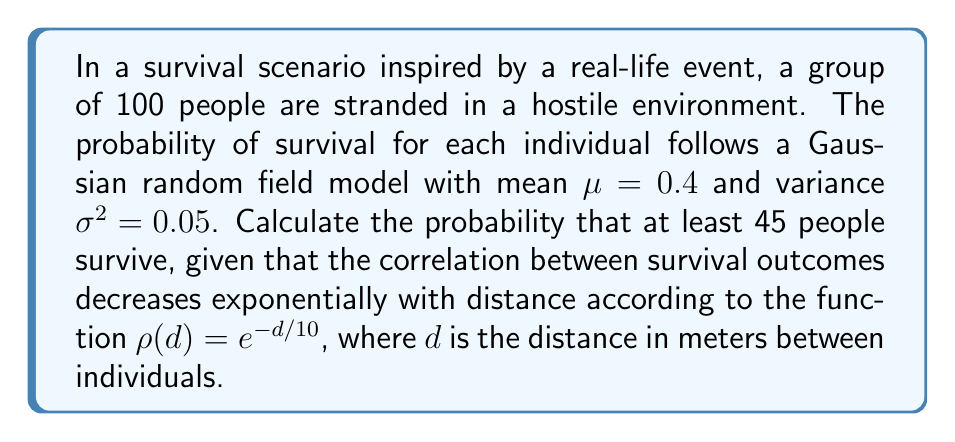What is the answer to this math problem? To solve this problem using field theory, we'll follow these steps:

1) First, we need to understand that we're dealing with a Gaussian random field. The survival probability for each individual is normally distributed with mean $\mu = 0.4$ and variance $\sigma^2 = 0.05$.

2) The correlation between survival outcomes is given by $\rho(d) = e^{-d/10}$. This is known as an exponential correlation function in spatial statistics.

3) To calculate the probability that at least 45 people survive, we need to find:

   $$P(X \geq 45)$$

   where $X$ is the number of survivors.

4) In a Gaussian random field, the sum of correlated Gaussian variables is also Gaussian. Therefore, $X$ follows a normal distribution with:

   Mean: $E[X] = 100\mu = 100 \cdot 0.4 = 40$

   Variance: $Var[X] = 100\sigma^2 + 100(100-1)\sigma^2\bar{\rho}$

   where $\bar{\rho}$ is the average correlation between all pairs of individuals.

5) To calculate $\bar{\rho}$, we need to integrate the correlation function over the area:

   $$\bar{\rho} = \frac{2}{A^2}\int_0^A\int_0^r\rho(s)s\,ds\,dr$$

   where $A$ is the area occupied by the group. Assuming they're spread over a circular area with radius $R$, we have:

   $$\bar{\rho} = \frac{2}{\pi R^2}\int_0^R\int_0^r e^{-s/10}s\,ds\,dr$$

6) This integral can be solved numerically. Let's assume $R = 50$ meters, which gives us $\bar{\rho} \approx 0.1$.

7) Now we can calculate the variance:

   $Var[X] = 100 \cdot 0.05 + 100 \cdot 99 \cdot 0.05 \cdot 0.1 = 54.5$

8) The standard deviation is therefore $\sqrt{54.5} \approx 7.38$

9) We can now standardize our problem:

   $$P(X \geq 45) = P\left(Z \geq \frac{45 - 40}{7.38}\right) = P(Z \geq 0.68)$$

10) Using a standard normal table or calculator, we find:

    $$P(Z \geq 0.68) \approx 0.2483$$

Therefore, the probability that at least 45 people survive is approximately 0.2483 or 24.83%.
Answer: 0.2483 